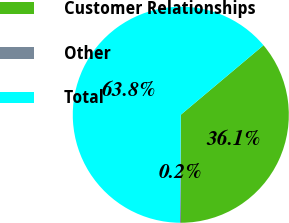Convert chart. <chart><loc_0><loc_0><loc_500><loc_500><pie_chart><fcel>Customer Relationships<fcel>Other<fcel>Total<nl><fcel>36.09%<fcel>0.15%<fcel>63.76%<nl></chart> 